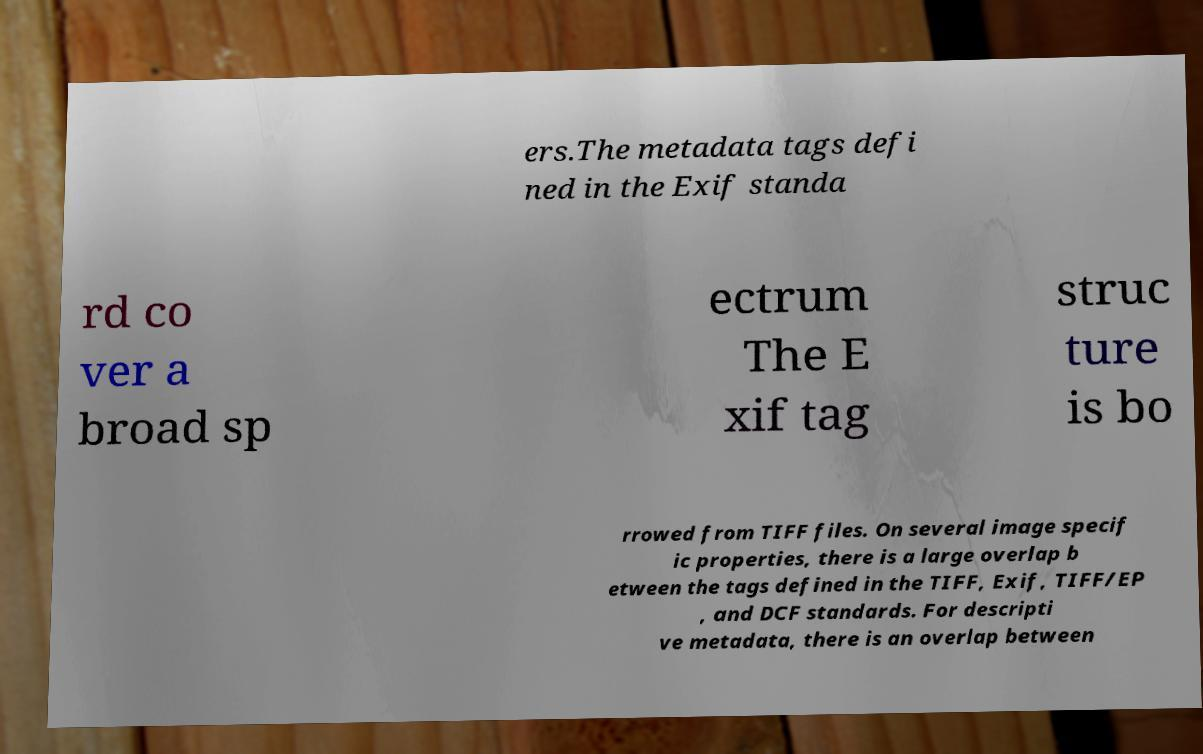Can you read and provide the text displayed in the image?This photo seems to have some interesting text. Can you extract and type it out for me? ers.The metadata tags defi ned in the Exif standa rd co ver a broad sp ectrum The E xif tag struc ture is bo rrowed from TIFF files. On several image specif ic properties, there is a large overlap b etween the tags defined in the TIFF, Exif, TIFF/EP , and DCF standards. For descripti ve metadata, there is an overlap between 